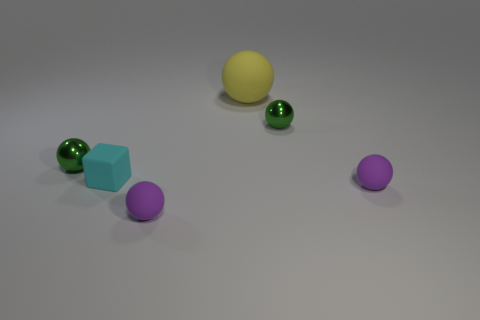Subtract all tiny purple rubber balls. How many balls are left? 3 Add 2 tiny rubber things. How many objects exist? 8 Subtract 2 balls. How many balls are left? 3 Subtract all yellow spheres. How many spheres are left? 4 Subtract all cyan blocks. How many purple balls are left? 2 Subtract all small green things. Subtract all cyan objects. How many objects are left? 3 Add 4 small cyan rubber cubes. How many small cyan rubber cubes are left? 5 Add 5 small red blocks. How many small red blocks exist? 5 Subtract 0 brown balls. How many objects are left? 6 Subtract all balls. How many objects are left? 1 